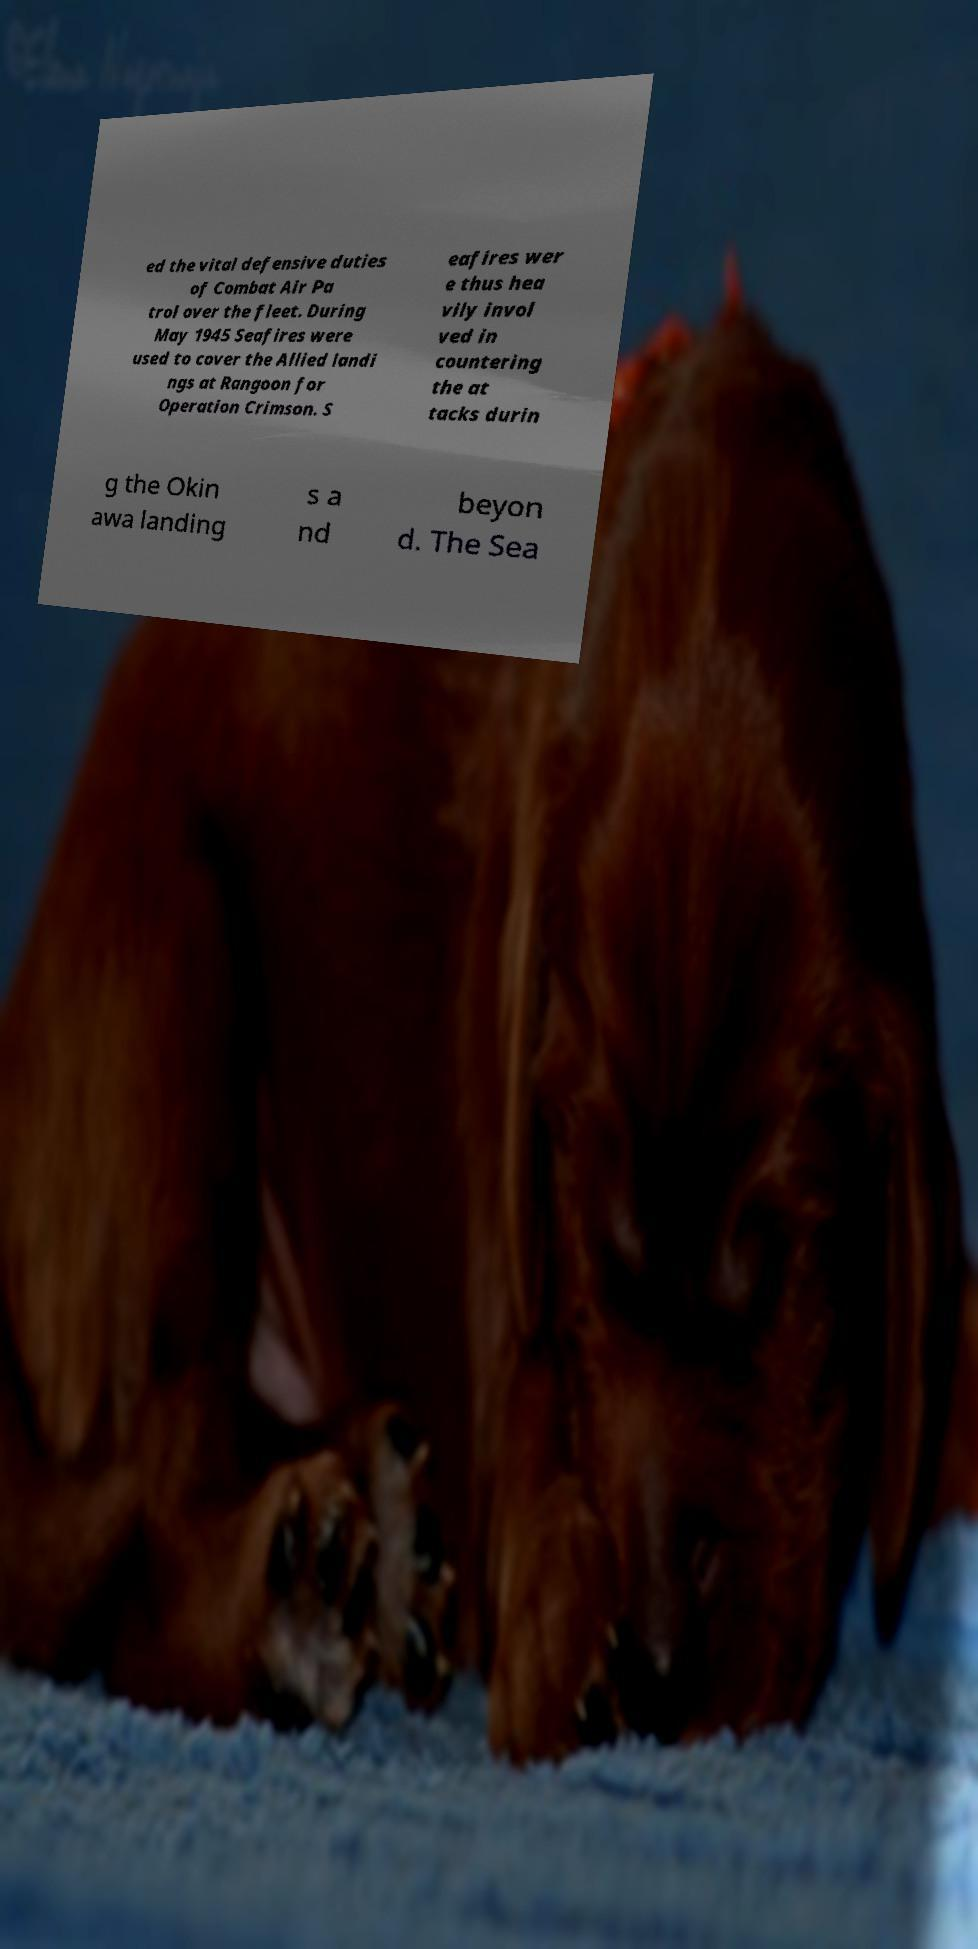What messages or text are displayed in this image? I need them in a readable, typed format. ed the vital defensive duties of Combat Air Pa trol over the fleet. During May 1945 Seafires were used to cover the Allied landi ngs at Rangoon for Operation Crimson. S eafires wer e thus hea vily invol ved in countering the at tacks durin g the Okin awa landing s a nd beyon d. The Sea 